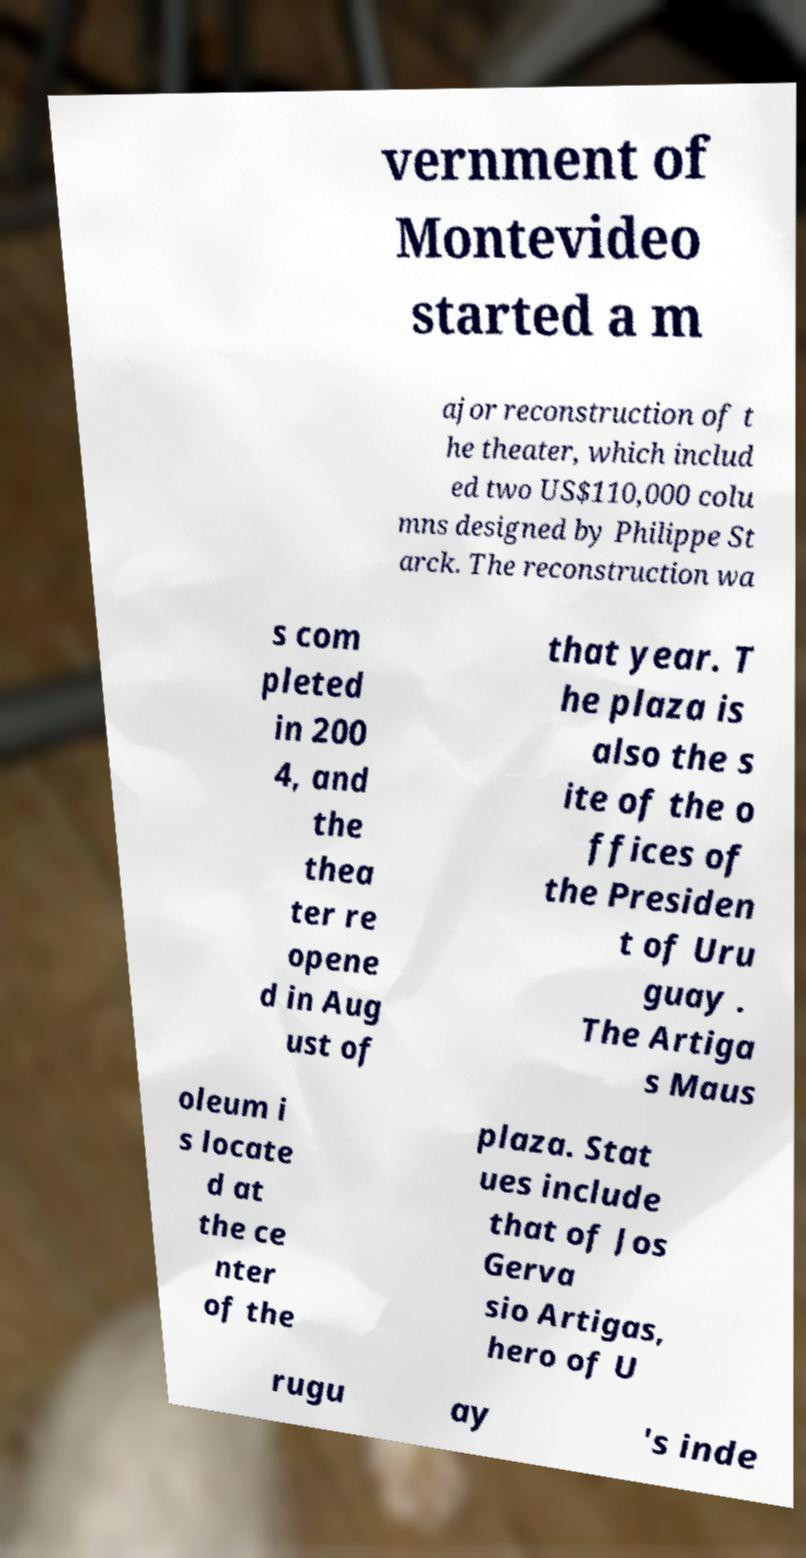Can you read and provide the text displayed in the image?This photo seems to have some interesting text. Can you extract and type it out for me? vernment of Montevideo started a m ajor reconstruction of t he theater, which includ ed two US$110,000 colu mns designed by Philippe St arck. The reconstruction wa s com pleted in 200 4, and the thea ter re opene d in Aug ust of that year. T he plaza is also the s ite of the o ffices of the Presiden t of Uru guay . The Artiga s Maus oleum i s locate d at the ce nter of the plaza. Stat ues include that of Jos Gerva sio Artigas, hero of U rugu ay 's inde 